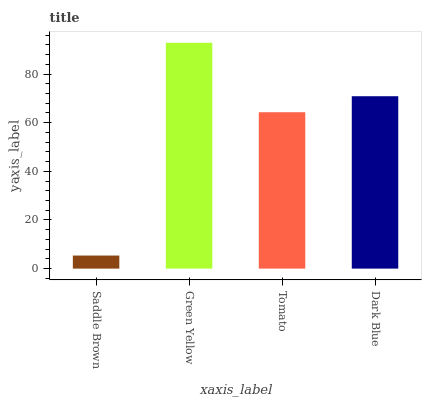Is Saddle Brown the minimum?
Answer yes or no. Yes. Is Green Yellow the maximum?
Answer yes or no. Yes. Is Tomato the minimum?
Answer yes or no. No. Is Tomato the maximum?
Answer yes or no. No. Is Green Yellow greater than Tomato?
Answer yes or no. Yes. Is Tomato less than Green Yellow?
Answer yes or no. Yes. Is Tomato greater than Green Yellow?
Answer yes or no. No. Is Green Yellow less than Tomato?
Answer yes or no. No. Is Dark Blue the high median?
Answer yes or no. Yes. Is Tomato the low median?
Answer yes or no. Yes. Is Green Yellow the high median?
Answer yes or no. No. Is Green Yellow the low median?
Answer yes or no. No. 